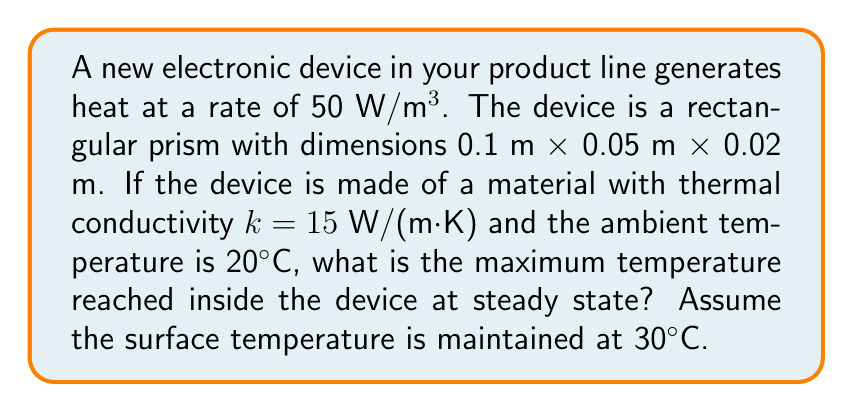Give your solution to this math problem. To solve this problem, we'll use the steady-state heat equation in three dimensions:

$$\frac{\partial^2 T}{\partial x^2} + \frac{\partial^2 T}{\partial y^2} + \frac{\partial^2 T}{\partial z^2} + \frac{q}{k} = 0$$

Where:
- $T$ is temperature
- $q$ is the heat generation rate per unit volume
- $k$ is the thermal conductivity

Given:
- Heat generation rate: $q = 50$ W/m³
- Dimensions: $L_x = 0.1$ m, $L_y = 0.05$ m, $L_z = 0.02$ m
- Thermal conductivity: $k = 15$ W/(m·K)
- Surface temperature: $T_s = 30°C$

Step 1: Simplify the problem using symmetry. The maximum temperature will occur at the center of the device.

Step 2: Use the following solution for the maximum temperature difference:

$$\Delta T_{max} = \frac{q}{8k}\left(\frac{L_x^2}{4} + \frac{L_y^2}{4} + \frac{L_z^2}{4}\right)$$

Step 3: Substitute the given values:

$$\Delta T_{max} = \frac{50}{8 \cdot 15}\left(\frac{0.1^2}{4} + \frac{0.05^2}{4} + \frac{0.02^2}{4}\right)$$

Step 4: Calculate $\Delta T_{max}$:

$$\Delta T_{max} = 0.4167 \cdot (0.0025 + 0.000625 + 0.0001) = 0.4167 \cdot 0.003125 = 0.001302°C$$

Step 5: Add $\Delta T_{max}$ to the surface temperature to get the maximum internal temperature:

$$T_{max} = T_s + \Delta T_{max} = 30°C + 0.001302°C = 30.001302°C$$
Answer: 30.001302°C 